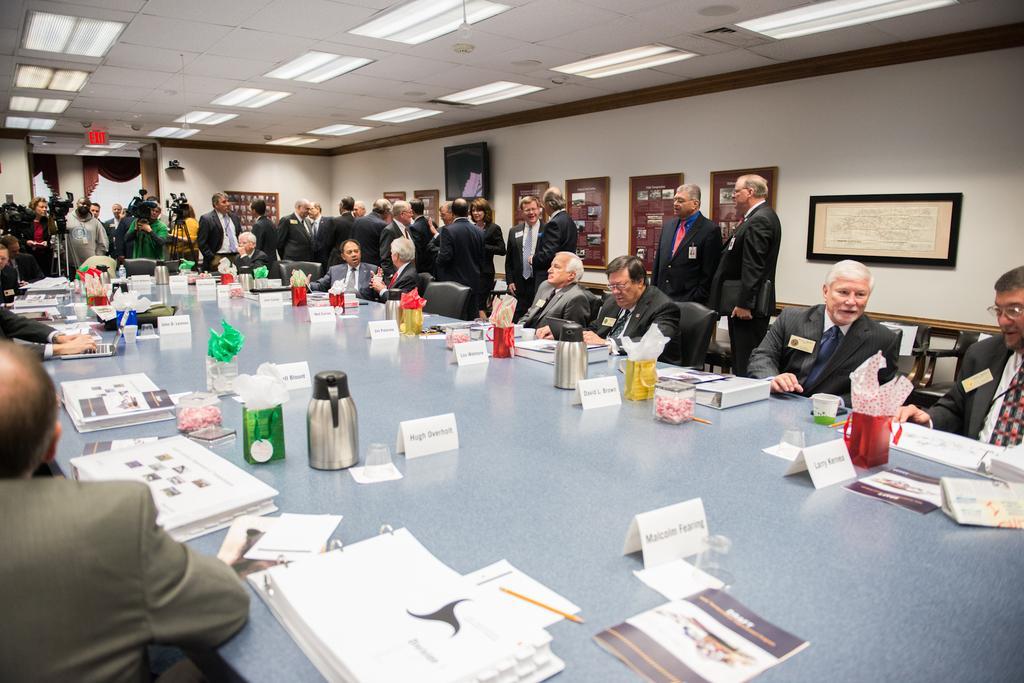Can you describe this image briefly? In the given image we can see many people some of them are sitting and some of them are standing. This is a table on which water bag is kept. 